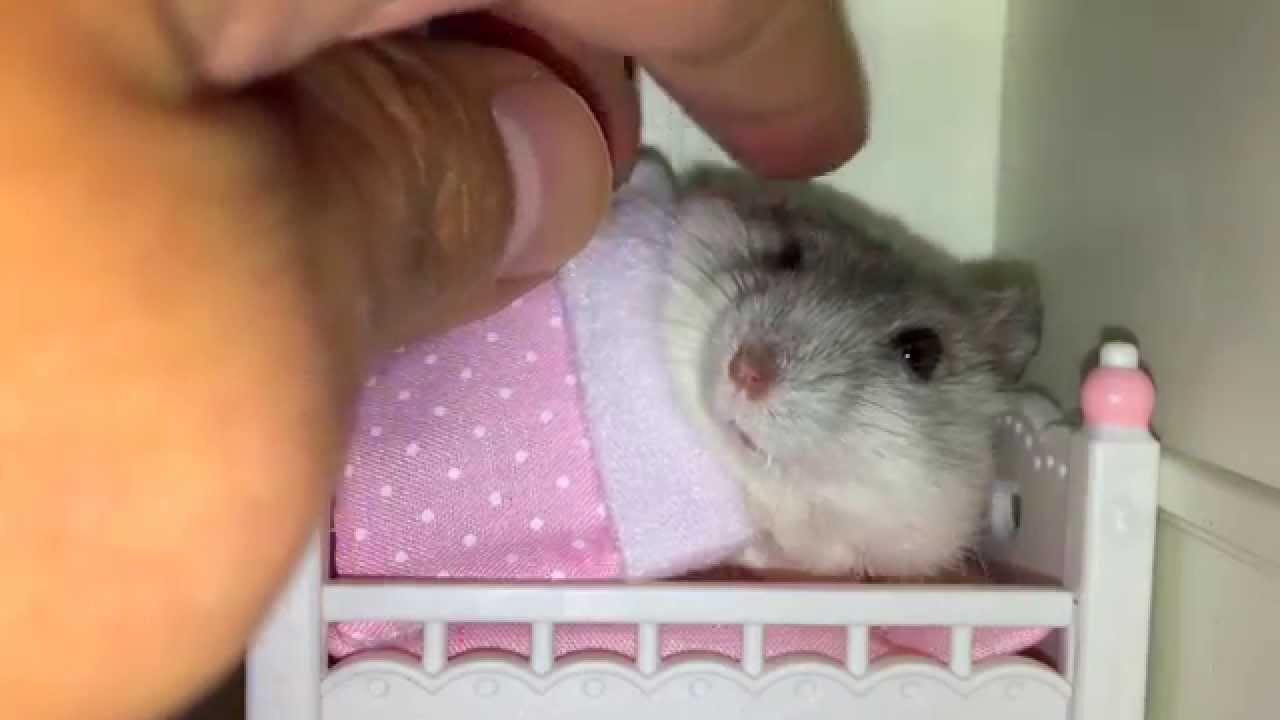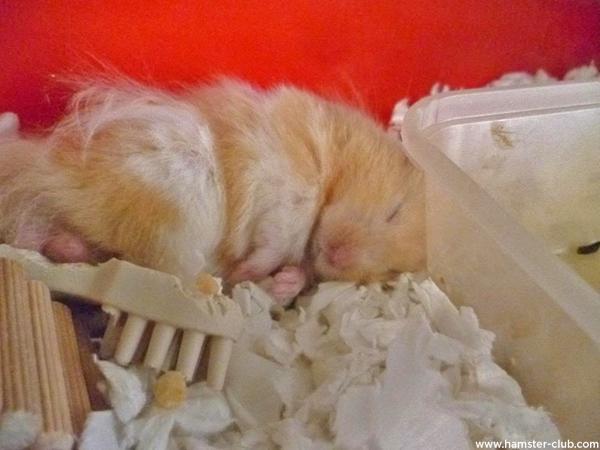The first image is the image on the left, the second image is the image on the right. For the images displayed, is the sentence "The hamster in the right image is sleeping." factually correct? Answer yes or no. Yes. The first image is the image on the left, the second image is the image on the right. Given the left and right images, does the statement "The rodent in one of the images is covered by a blanket." hold true? Answer yes or no. Yes. 